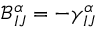<formula> <loc_0><loc_0><loc_500><loc_500>\mathcal { B } _ { I J } ^ { \alpha } = - \gamma _ { I J } ^ { \alpha }</formula> 